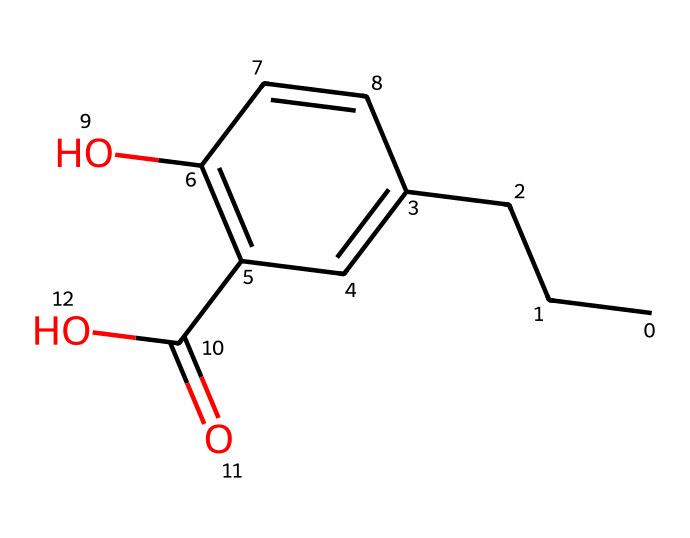How many carbon atoms are present in propylparaben? The SMILES representation shows a chain of carbon atoms (CCCC) followed by a ring structure (C1) that contains additional carbons. Counting these, there are a total of 10 carbon atoms.
Answer: 10 What is the functional group present in propylparaben? From the structure depicted by the SMILES, there is a hydroxyl group (-OH) attached to a carbon in the ring and a carboxylic acid group (-COOH) seen at the end of the chain. The presence of these groups indicates that the functional groups are hydroxyl and carboxylic acid.
Answer: hydroxyl and carboxylic acid How many double bonds are present in the structure of propylparaben? Examining the SMILES representation, there are two double bonds indicated (C=C) within the ring. Therefore, the total number of double bonds in propylparaben is two.
Answer: 2 What type of compound is propylparaben classified as? Considering the structure and functional groups, propylparaben is characterized as a paraben, which is a type of ester and preservative used in cosmetics and food products.
Answer: preservative Is propylparaben polar or nonpolar? The presence of the hydroxyl and carboxylic acid functional groups contributes to polarity. Since these groups are hydrophilic, the overall molecule exhibits polar characteristics.
Answer: polar What is the total number of oxygen atoms in propylparaben? In the provided chemical structure, there are two oxygen atoms visible in the carboxylic acid group and one in the hydroxyl group, leading to a total count of three oxygen atoms.
Answer: 3 